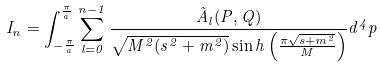<formula> <loc_0><loc_0><loc_500><loc_500>I _ { n } = \int ^ { \frac { \pi } { a } } _ { - \frac { \pi } { a } } \sum ^ { n - 1 } _ { l = 0 } \frac { \tilde { A } _ { l } ( P , Q ) } { \sqrt { M ^ { 2 } ( s ^ { 2 } + m ^ { 2 } ) } \sin h \left ( \frac { \pi \sqrt { s + m ^ { 2 } } } { M } \right ) } d ^ { 4 } p</formula> 